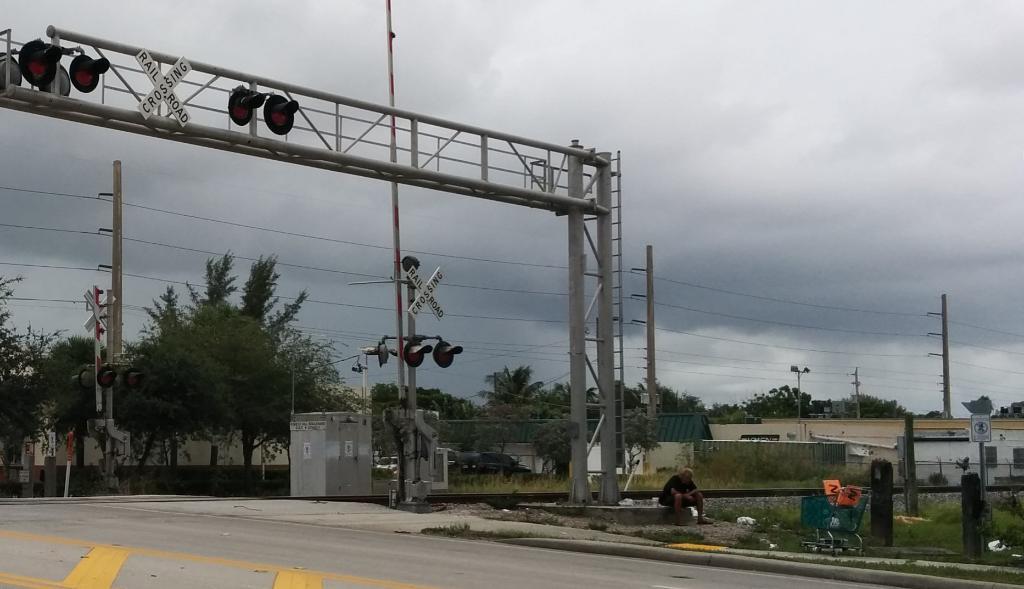What is the place name?
Ensure brevity in your answer.  Unanswerable. 